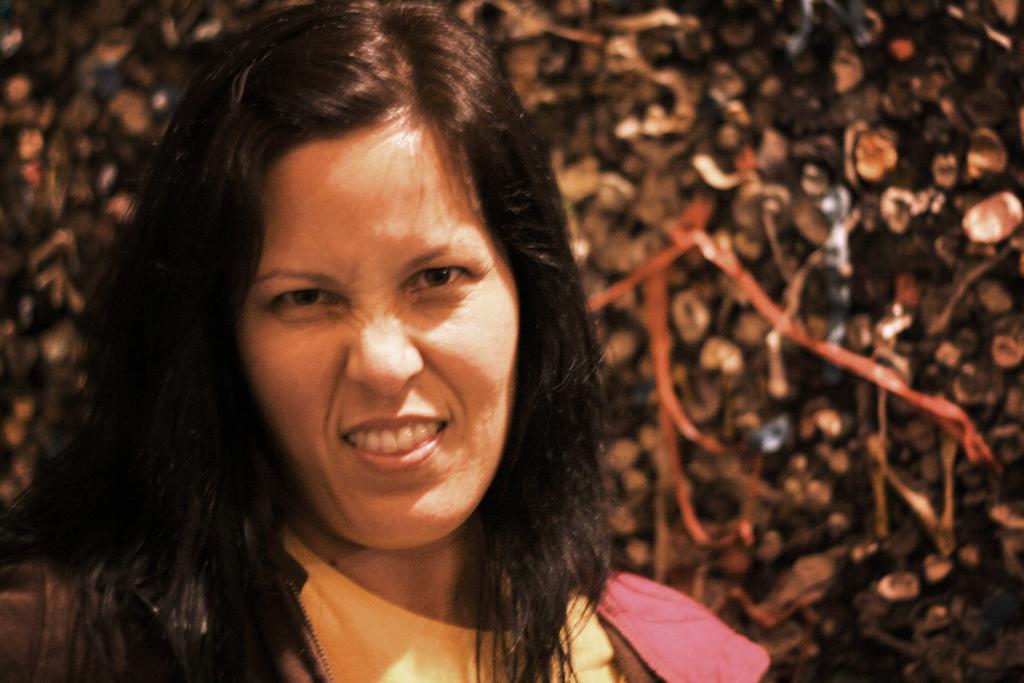Could you give a brief overview of what you see in this image? In the image there is a woman in the foreground, the background of the woman is blur. 